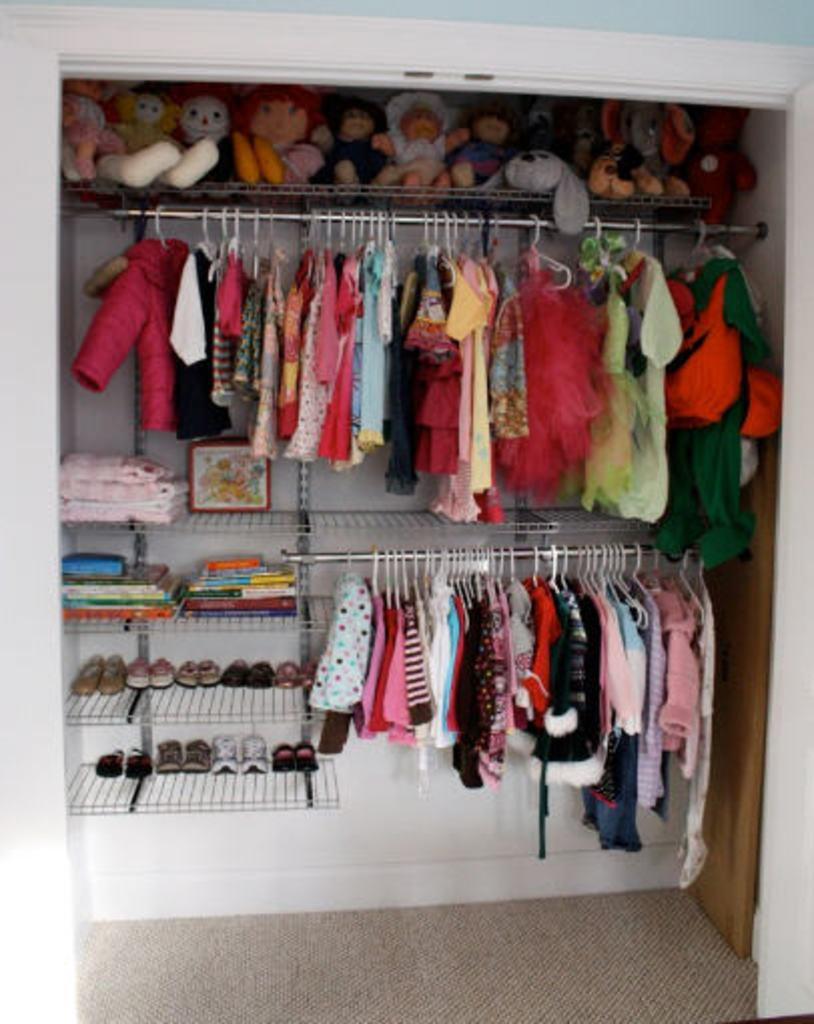How would you summarize this image in a sentence or two? In this image, we can see there are clothes, slippers and dolls arranged. At the bottom of this image, there is a carpet on the floor. On the right side, there is a wooden door. In the background, there is a white wall. 